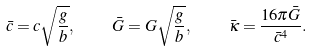<formula> <loc_0><loc_0><loc_500><loc_500>\bar { c } = c \sqrt { \frac { g } { b } } , \quad \bar { G } = G \sqrt { \frac { g } { b } } , \quad \bar { \kappa } = \frac { 1 6 \pi \bar { G } } { \bar { c } ^ { 4 } } .</formula> 